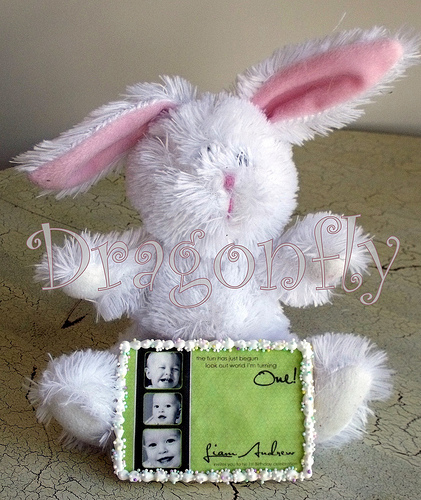<image>
Is the baby on the rabbit? No. The baby is not positioned on the rabbit. They may be near each other, but the baby is not supported by or resting on top of the rabbit. Is the bunny behind the frame? Yes. From this viewpoint, the bunny is positioned behind the frame, with the frame partially or fully occluding the bunny. 